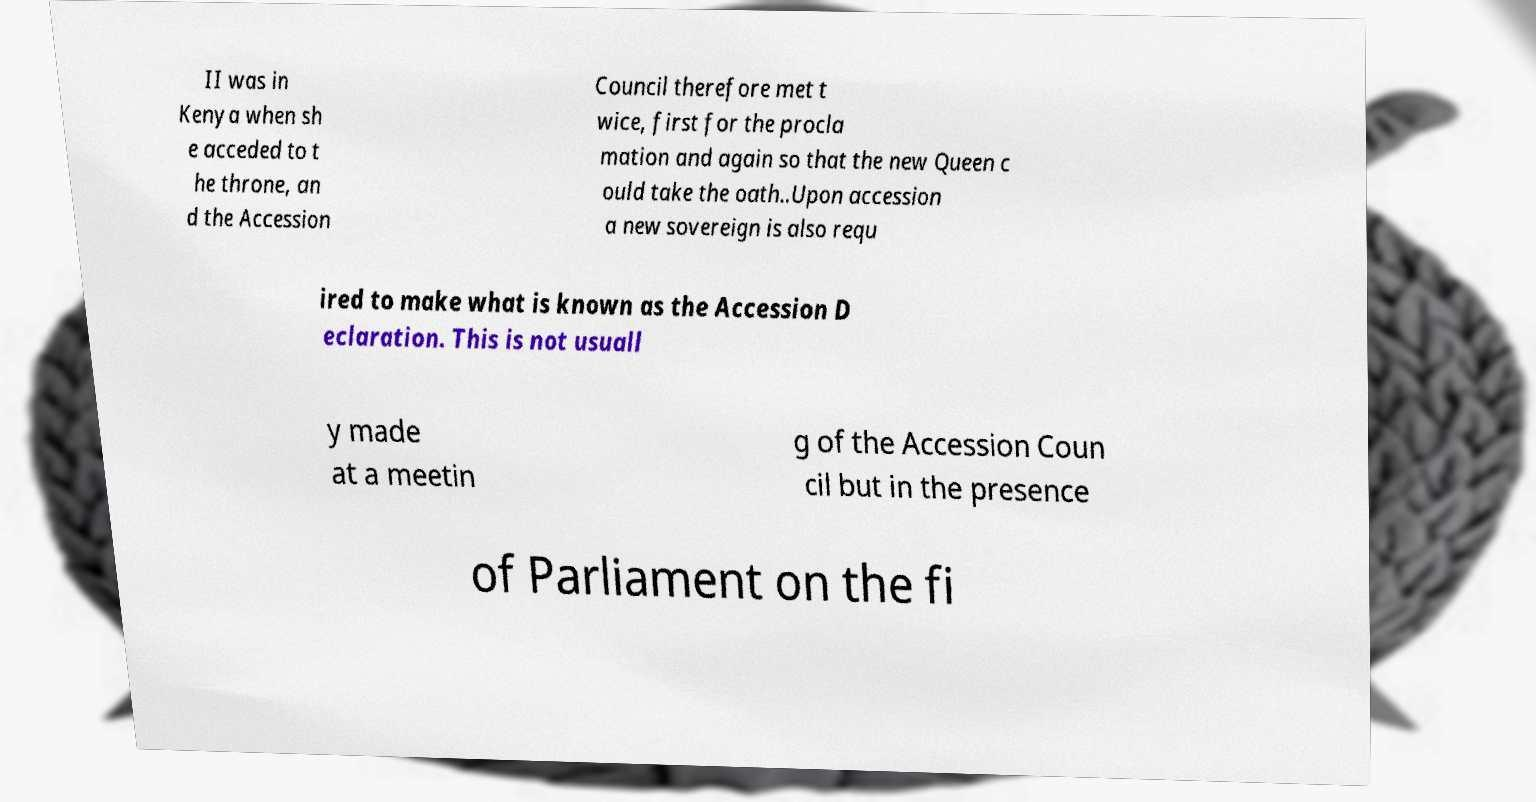Please read and relay the text visible in this image. What does it say? II was in Kenya when sh e acceded to t he throne, an d the Accession Council therefore met t wice, first for the procla mation and again so that the new Queen c ould take the oath..Upon accession a new sovereign is also requ ired to make what is known as the Accession D eclaration. This is not usuall y made at a meetin g of the Accession Coun cil but in the presence of Parliament on the fi 